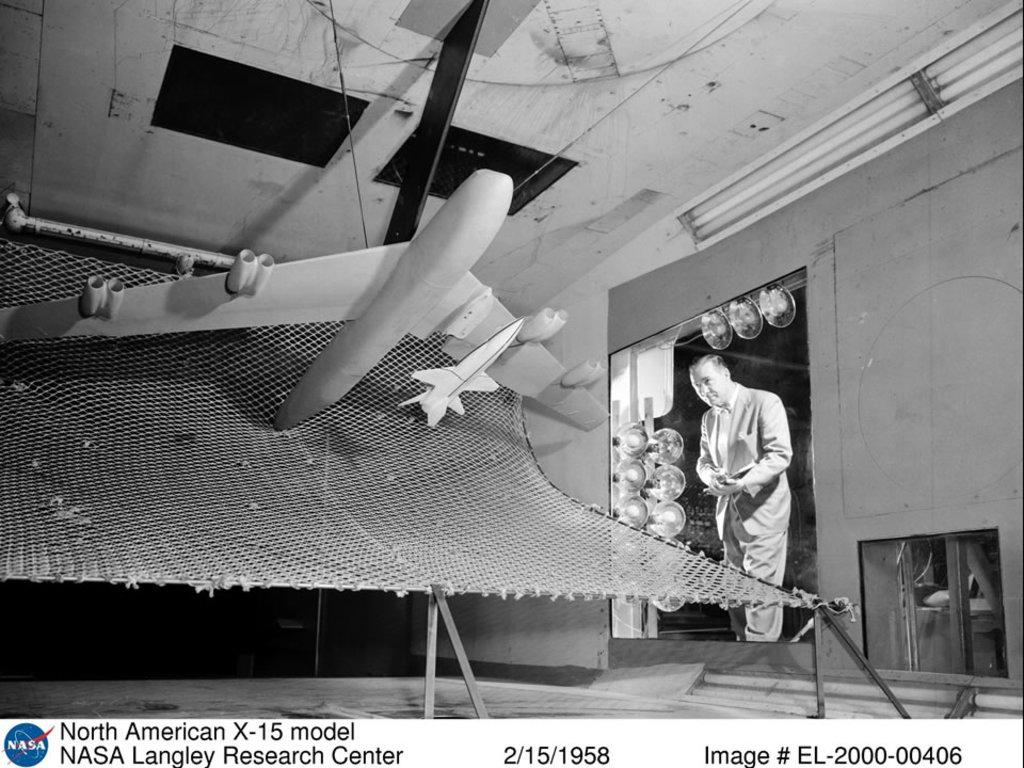<image>
Render a clear and concise summary of the photo. A black and white photo from NASA was taken in 1958 and shows a man looking at a model plane. 